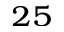Convert formula to latex. <formula><loc_0><loc_0><loc_500><loc_500>^ { 2 5 }</formula> 